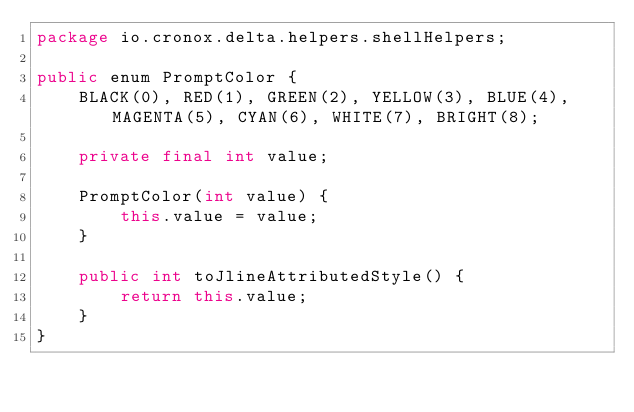<code> <loc_0><loc_0><loc_500><loc_500><_Java_>package io.cronox.delta.helpers.shellHelpers;

public enum PromptColor {
	BLACK(0), RED(1), GREEN(2), YELLOW(3), BLUE(4), MAGENTA(5), CYAN(6), WHITE(7), BRIGHT(8);

	private final int value;

	PromptColor(int value) {
		this.value = value;
	}

	public int toJlineAttributedStyle() {
		return this.value;
	}
}</code> 